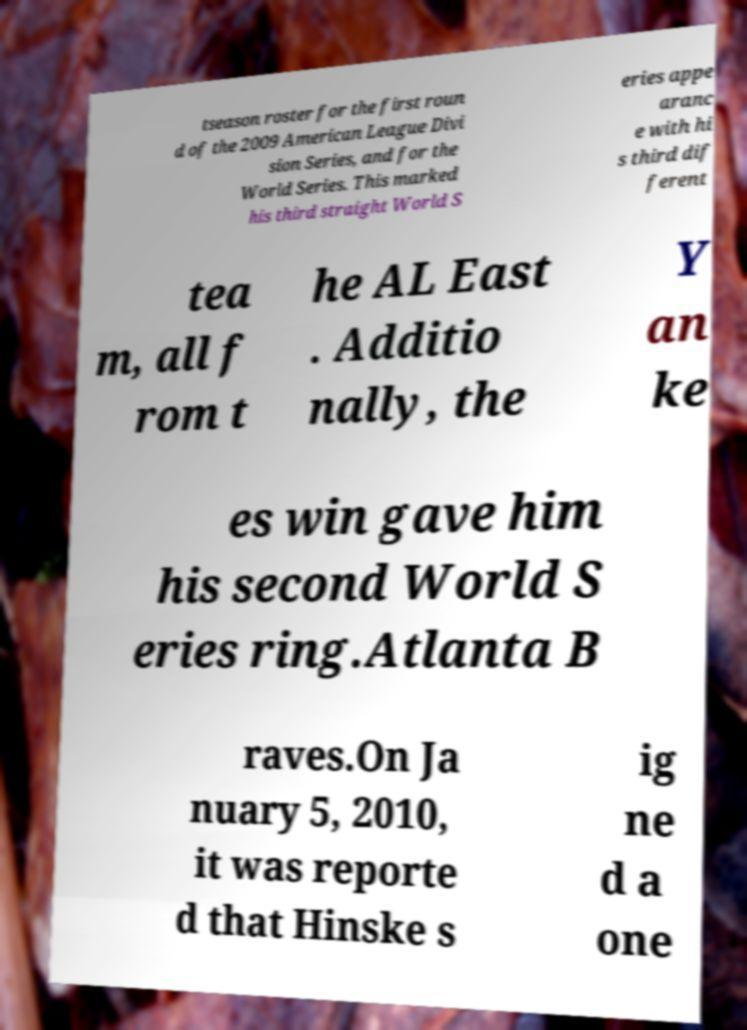Please read and relay the text visible in this image. What does it say? tseason roster for the first roun d of the 2009 American League Divi sion Series, and for the World Series. This marked his third straight World S eries appe aranc e with hi s third dif ferent tea m, all f rom t he AL East . Additio nally, the Y an ke es win gave him his second World S eries ring.Atlanta B raves.On Ja nuary 5, 2010, it was reporte d that Hinske s ig ne d a one 